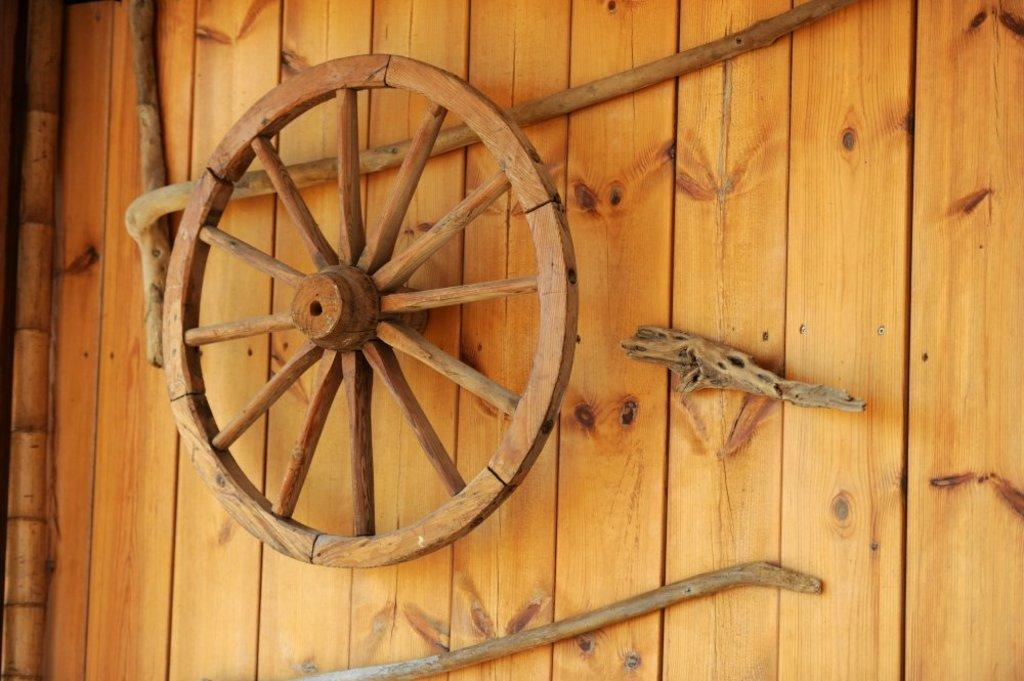What type of material is used for the wall in the image? The wall in the image is made of wood. What is the main object in the center of the image? There is a wheel in the center of the image. What other objects can be seen in the image? There are sticks present in the image. How does the beginner tie a knot with the sticks in the image? There are no people or actions depicted in the image, so it is not possible to determine how a beginner might tie a knot with the sticks. 